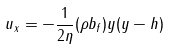<formula> <loc_0><loc_0><loc_500><loc_500>u _ { x } = - \frac { 1 } { 2 \eta } ( \rho b _ { f } ) y ( y - h )</formula> 